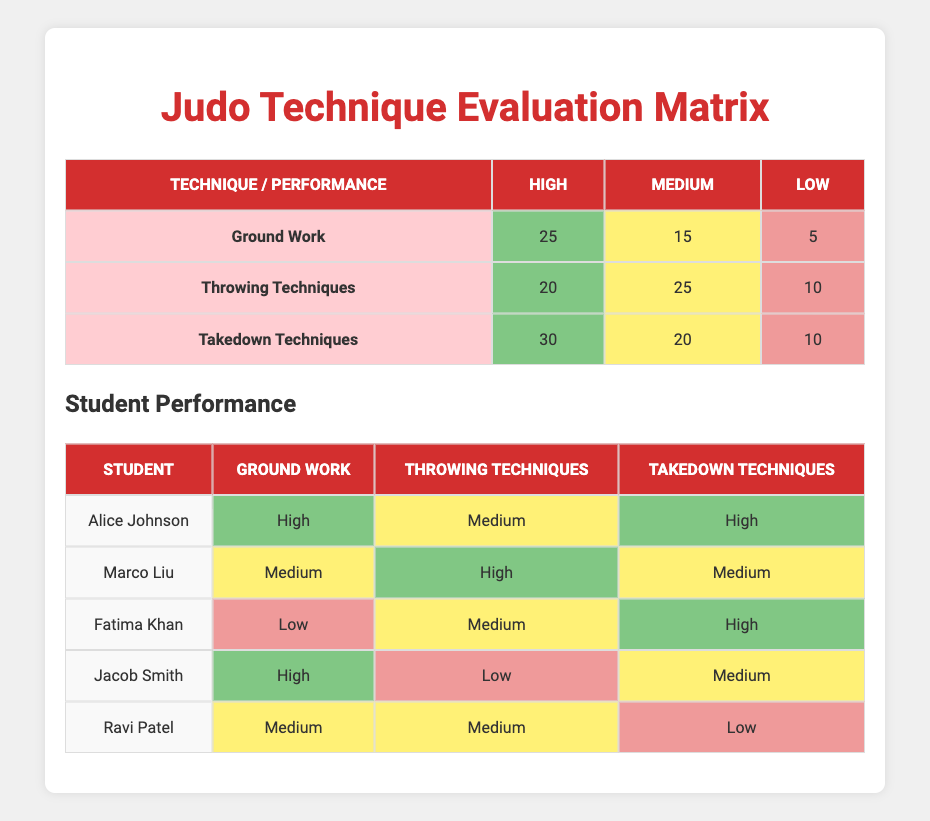What is the total number of students classified as "high" in Takedown Techniques? There are three students categorized as "high" in Takedown Techniques: Alice Johnson, Fatima Khan, and Jacob Smith. Thus, the total number is 3.
Answer: 3 What is the average classification for Ground Work among all students? The classifications for Ground Work are: High (2), Medium (2), and Low (1). To find the average, we can assign values: High = 3, Medium = 2, Low = 1. Therefore, (3*2 + 2*2 + 1*1) / 5 = (6 + 4 + 1) / 5 = 11 / 5 = 2.2, which rounds down to Medium.
Answer: Medium Does any student have a "low" classification for both Throwing Techniques and Ground Work? Marco Liu has a Medium classification for Ground Work and a High for Throwing Techniques. None of the students have a low classification in both areas; thus, the answer is no.
Answer: No What technique has the highest number of students classified as "medium"? The Throwing Techniques has 25 students classified as medium, compared to 15 in Ground Work and 20 in Takedown Techniques, making it the technique with the highest classification indicating medium performance.
Answer: Throwing Techniques How many students received a "high" rating in both Ground Work and Takedown Techniques? Alice Johnson and Jacob Smith both received "high" ratings in Ground Work and Takedown Techniques. Thus, there are 2 students with that classification in both techniques.
Answer: 2 Which technique has the lowest number of students classified as "low"? Ground Work has the lowest number of "low" classifications with just 5 students, whereas Throwing Techniques has 10 and Takedown Techniques has 10 as well. So, Ground Work is the technique with the least number of students scoring low.
Answer: Ground Work Are there more students with a "medium" or "low" classification in Throwing Techniques? For Throwing Techniques, there are 25 students in the medium category and 10 in the low category. Hence, there are more students classified as medium in this technique.
Answer: Medium What is the total number of students across all classifications for Takedown Techniques? Adding up the students: 30 in "high," 20 in "medium," and 10 in "low," gives us a total of 30 + 20 + 10 = 60 students in Takedown Techniques.
Answer: 60 